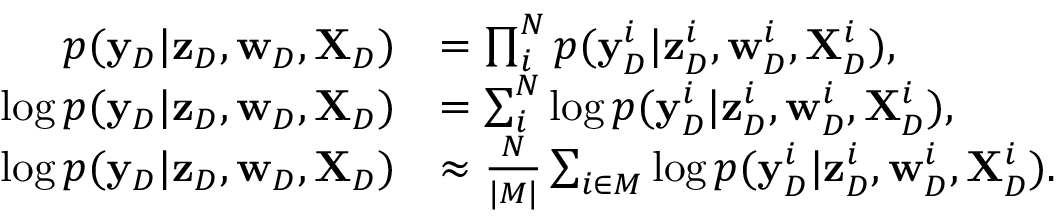<formula> <loc_0><loc_0><loc_500><loc_500>\begin{array} { r l } { p ( { \mathbf y } _ { D } | { \mathbf z } _ { D } , { \mathbf w } _ { D } , { \mathbf X } _ { D } ) } & { = \prod _ { i } ^ { N } p ( { \mathbf y } _ { D } ^ { i } | { \mathbf z } _ { D } ^ { i } , { \mathbf w } _ { D } ^ { i } , { \mathbf X } _ { D } ^ { i } ) , } \\ { \log p ( { \mathbf y } _ { D } | { \mathbf z } _ { D } , { \mathbf w } _ { D } , { \mathbf X } _ { D } ) } & { = \sum _ { i } ^ { N } \log p ( { \mathbf y } _ { D } ^ { i } | { \mathbf z } _ { D } ^ { i } , { \mathbf w } _ { D } ^ { i } , { \mathbf X } _ { D } ^ { i } ) , } \\ { \log p ( { \mathbf y } _ { D } | { \mathbf z } _ { D } , { \mathbf w } _ { D } , { \mathbf X } _ { D } ) } & { \approx \frac { N } { | M | } \sum _ { i \in M } \log p ( { \mathbf y } _ { D } ^ { i } | { \mathbf z } _ { D } ^ { i } , { \mathbf w } _ { D } ^ { i } , { \mathbf X } _ { D } ^ { i } ) . } \end{array}</formula> 